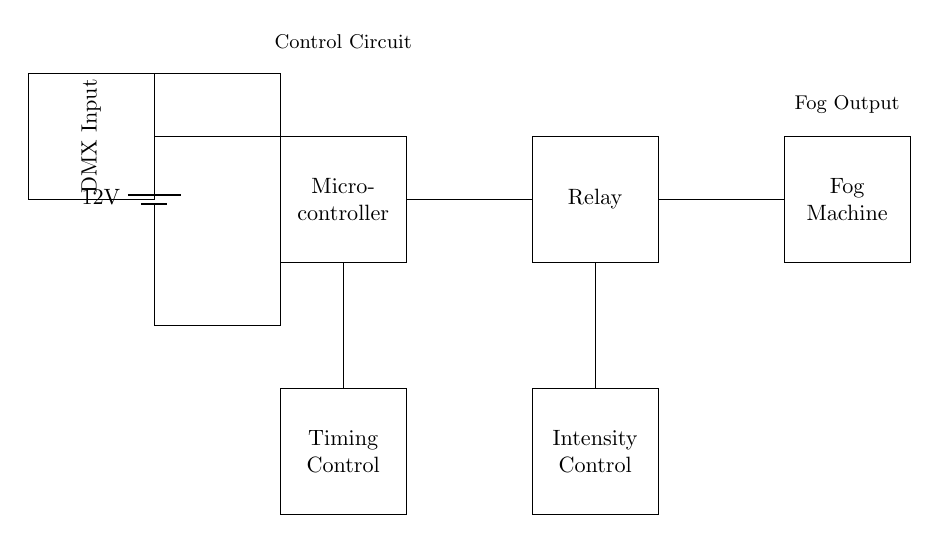What is the voltage of the power supply? The voltage is indicated on the battery symbol in the circuit, which shows 12 volts.
Answer: 12 volts What components are connected to the microcontroller? The microcontroller connects to the battery, relay, and timing control. This can be seen through the lines connecting those components directly to the microcontroller.
Answer: Battery, Relay, Timing Control What is the role of the relay in this circuit? The relay acts as a switch to control the fog machine based on signals from the microcontroller. This function can be inferred from its placement after the microcontroller in the circuit flow towards the fog machine.
Answer: Switch Which component controls the intensity of the fog machine? The intensity control component is connected directly to the relay and is labeled as such in the diagram. It indicates that this part manages the fog output's strength, influencing the machine's operation.
Answer: Intensity Control How many main control components are present in the circuit? The circuit includes three main control components: the timing control, the intensity control, and the microcontroller. This total is determined from the distinct boxes labeled within the diagram.
Answer: Three What type of input does the circuit receive? The circuit receives a DMX input, which is specifically indicated in the labeled rectangle before the microcontroller. This input type is common in theatrical lighting and effects control.
Answer: DMX Input 